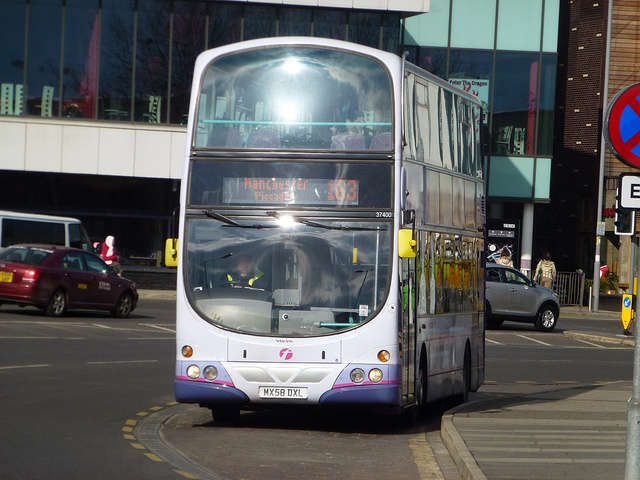Describe the objects in this image and their specific colors. I can see bus in black, gray, darkgray, and lightgray tones, car in black, maroon, gray, and blue tones, car in black and gray tones, car in black, gray, darkgray, and lightgray tones, and people in black, gray, darkblue, and khaki tones in this image. 